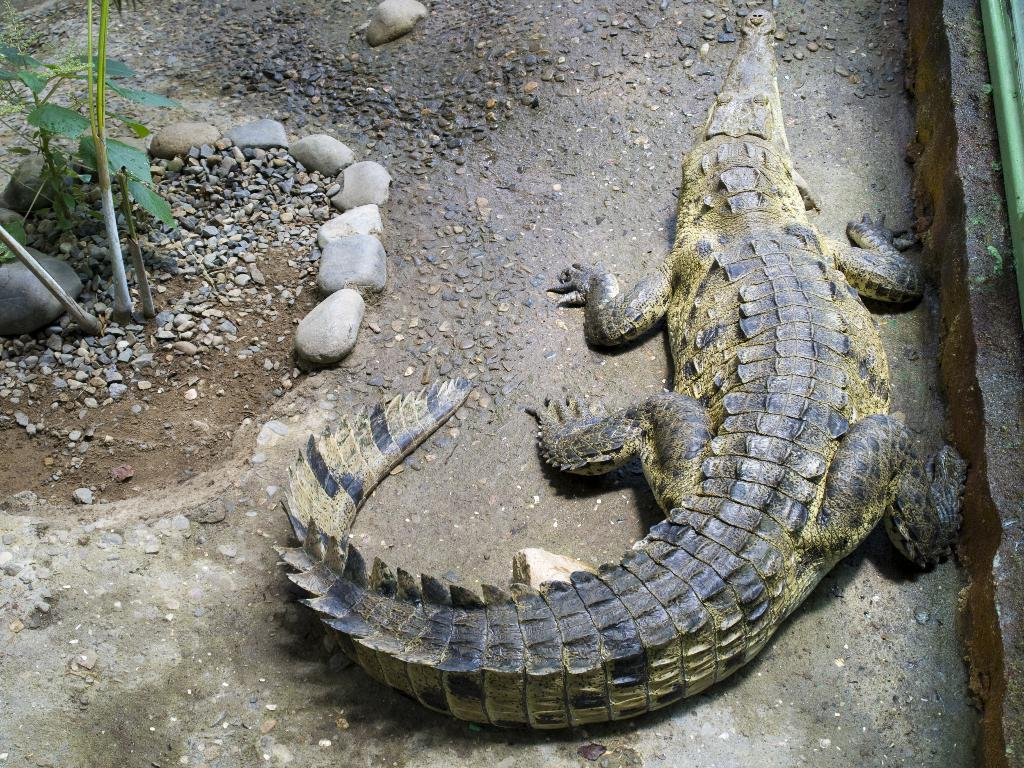What is the main subject in the foreground of the image? There is a crocodile in the foreground of the image, on the right side. What can be seen on the opposite side of the image? There are plants on the left side of the image. What type of terrain is depicted in the image? The area is surrounded by stones. What type of thread is being used by the crocodile in the image? There is no thread present in the image, and the crocodile is not using any thread. 